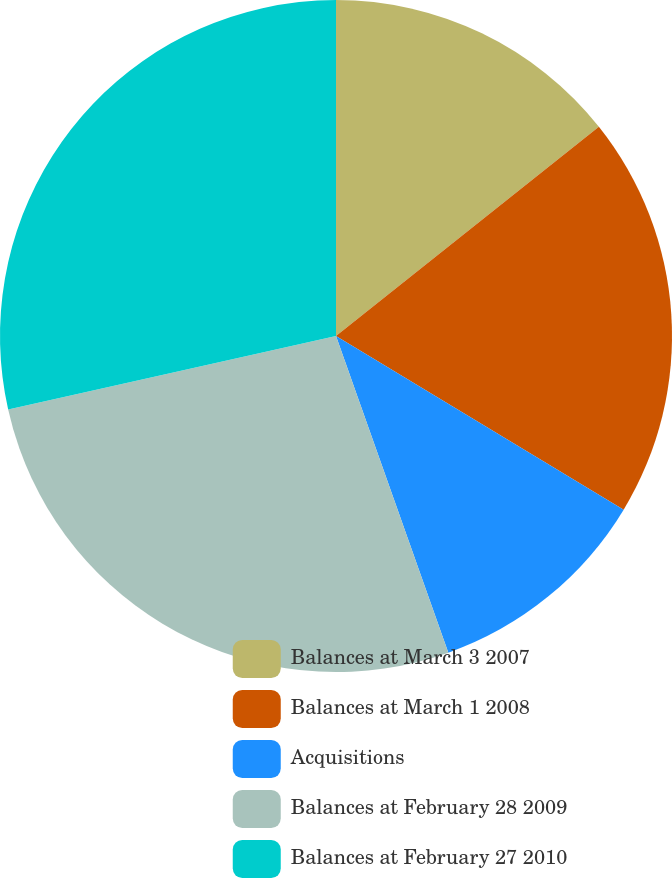Convert chart to OTSL. <chart><loc_0><loc_0><loc_500><loc_500><pie_chart><fcel>Balances at March 3 2007<fcel>Balances at March 1 2008<fcel>Acquisitions<fcel>Balances at February 28 2009<fcel>Balances at February 27 2010<nl><fcel>14.3%<fcel>19.34%<fcel>10.93%<fcel>26.91%<fcel>28.51%<nl></chart> 